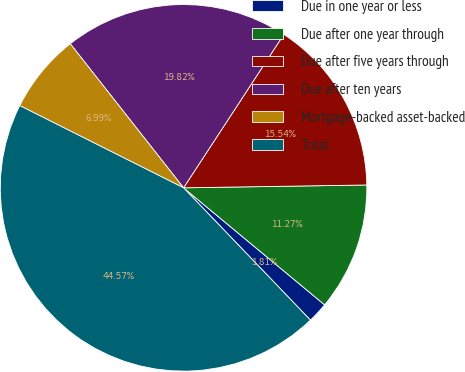Convert chart to OTSL. <chart><loc_0><loc_0><loc_500><loc_500><pie_chart><fcel>Due in one year or less<fcel>Due after one year through<fcel>Due after five years through<fcel>Due after ten years<fcel>Mortgage-backed asset-backed<fcel>Total<nl><fcel>1.81%<fcel>11.27%<fcel>15.54%<fcel>19.82%<fcel>6.99%<fcel>44.57%<nl></chart> 